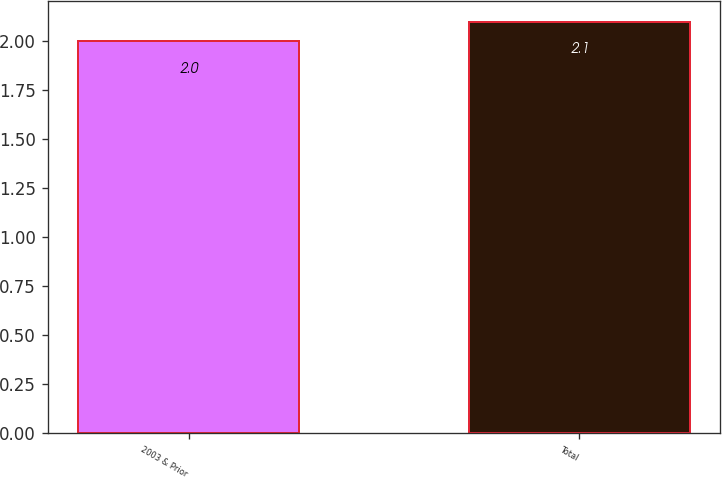<chart> <loc_0><loc_0><loc_500><loc_500><bar_chart><fcel>2003 & Prior<fcel>Total<nl><fcel>2<fcel>2.1<nl></chart> 